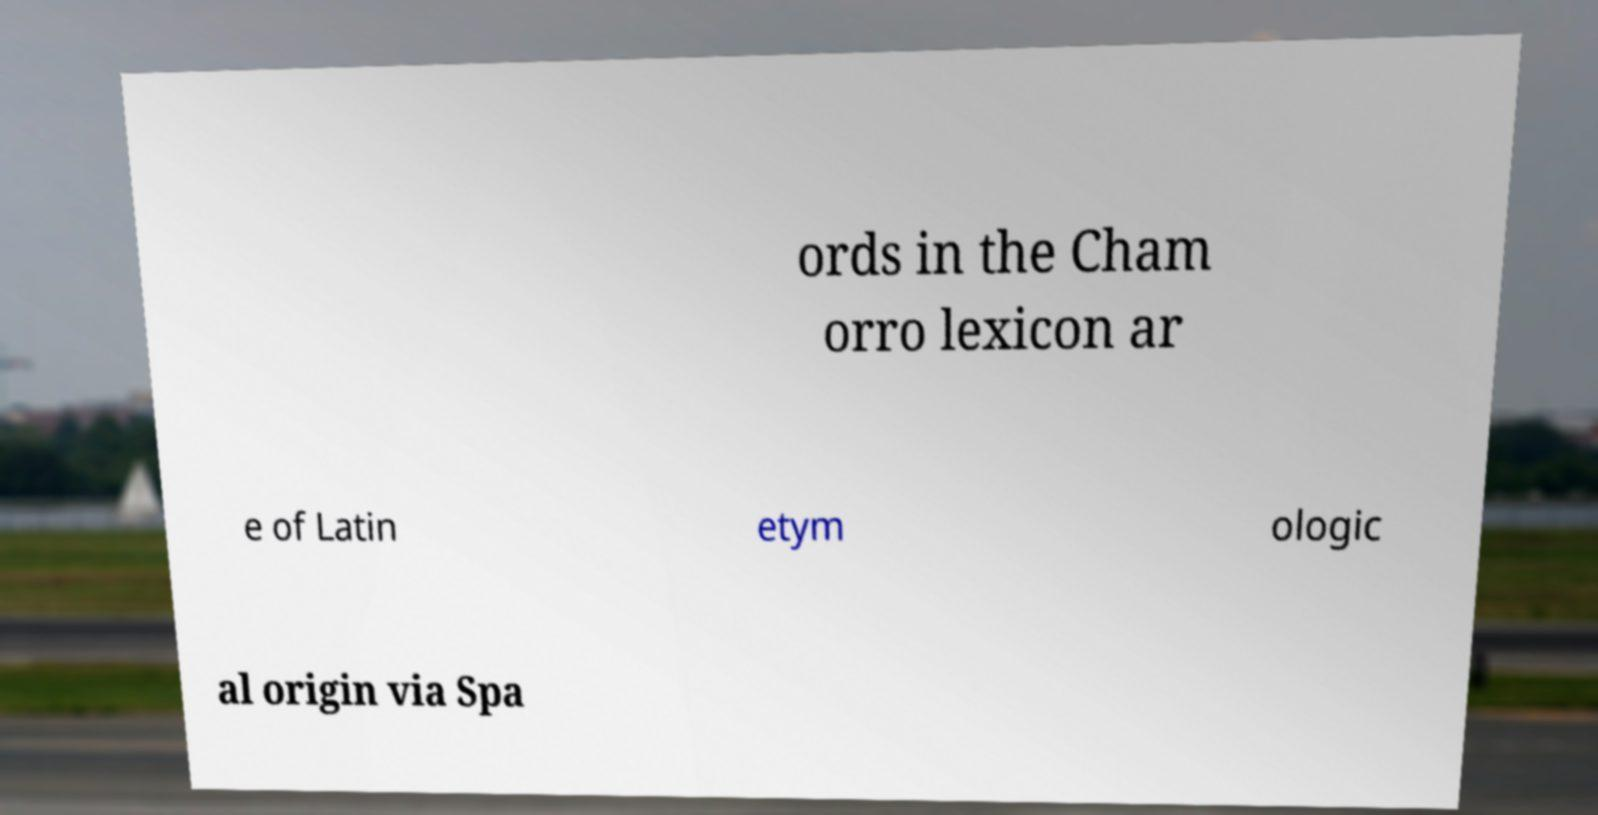Could you assist in decoding the text presented in this image and type it out clearly? ords in the Cham orro lexicon ar e of Latin etym ologic al origin via Spa 